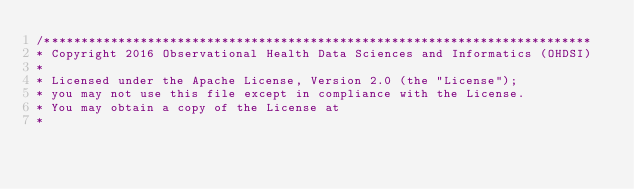<code> <loc_0><loc_0><loc_500><loc_500><_SQL_>/**************************************************************************
* Copyright 2016 Observational Health Data Sciences and Informatics (OHDSI)
*
* Licensed under the Apache License, Version 2.0 (the "License");
* you may not use this file except in compliance with the License.
* You may obtain a copy of the License at
*</code> 